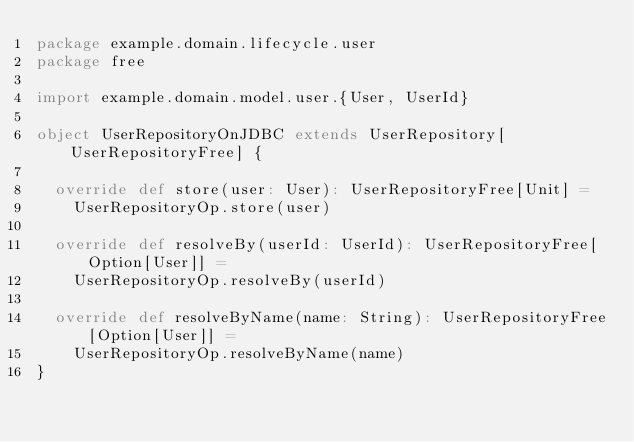Convert code to text. <code><loc_0><loc_0><loc_500><loc_500><_Scala_>package example.domain.lifecycle.user
package free

import example.domain.model.user.{User, UserId}

object UserRepositoryOnJDBC extends UserRepository[UserRepositoryFree] {

  override def store(user: User): UserRepositoryFree[Unit] =
    UserRepositoryOp.store(user)

  override def resolveBy(userId: UserId): UserRepositoryFree[Option[User]] =
    UserRepositoryOp.resolveBy(userId)

  override def resolveByName(name: String): UserRepositoryFree[Option[User]] =
    UserRepositoryOp.resolveByName(name)
}

</code> 